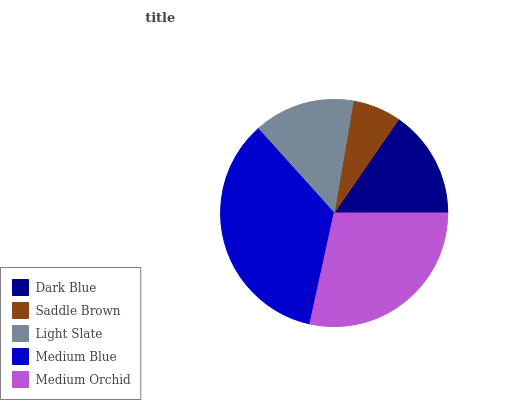Is Saddle Brown the minimum?
Answer yes or no. Yes. Is Medium Blue the maximum?
Answer yes or no. Yes. Is Light Slate the minimum?
Answer yes or no. No. Is Light Slate the maximum?
Answer yes or no. No. Is Light Slate greater than Saddle Brown?
Answer yes or no. Yes. Is Saddle Brown less than Light Slate?
Answer yes or no. Yes. Is Saddle Brown greater than Light Slate?
Answer yes or no. No. Is Light Slate less than Saddle Brown?
Answer yes or no. No. Is Dark Blue the high median?
Answer yes or no. Yes. Is Dark Blue the low median?
Answer yes or no. Yes. Is Medium Blue the high median?
Answer yes or no. No. Is Saddle Brown the low median?
Answer yes or no. No. 